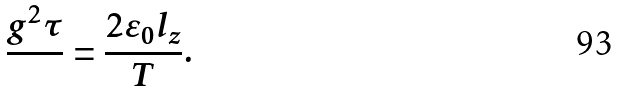<formula> <loc_0><loc_0><loc_500><loc_500>\frac { g ^ { 2 } \tau } { } = \frac { 2 \varepsilon _ { 0 } l _ { z } } { T } .</formula> 